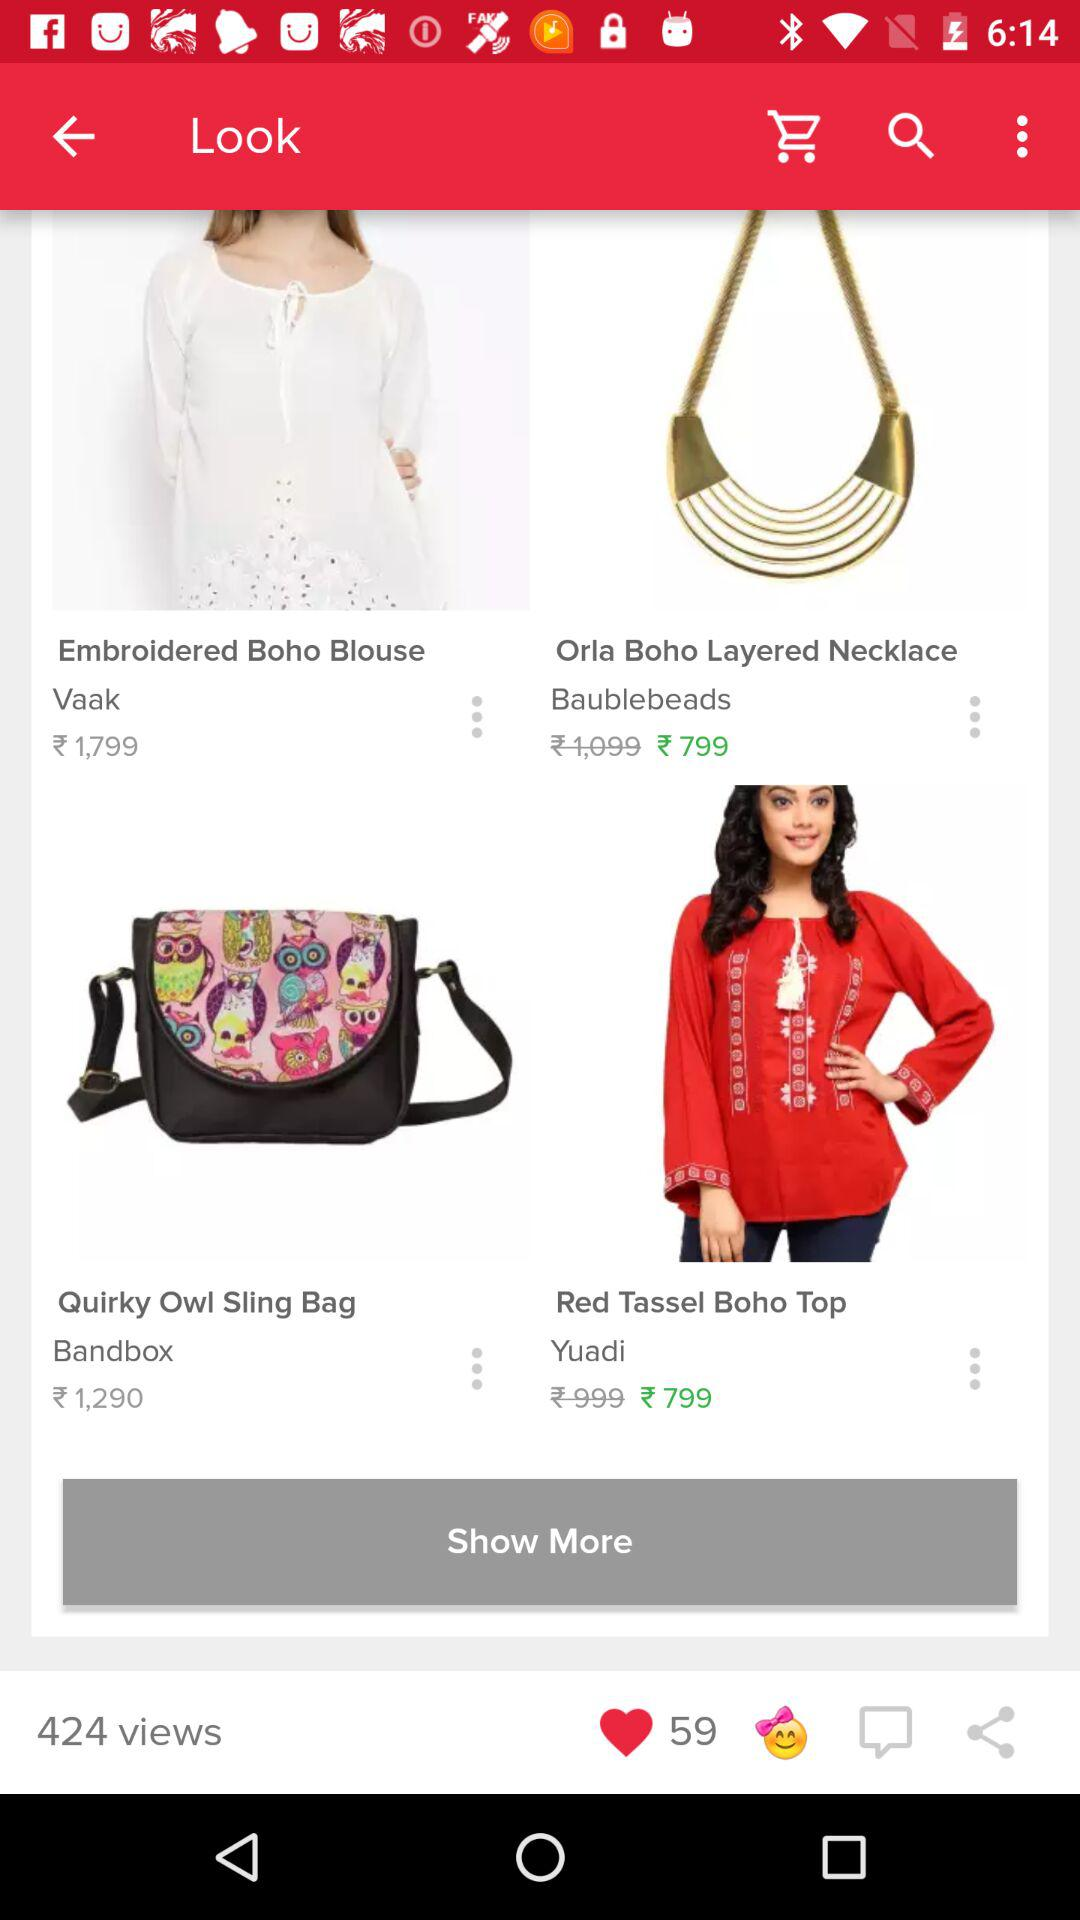What is the cost of the orla boho layered necklace after discount? The cost is ₹799. 